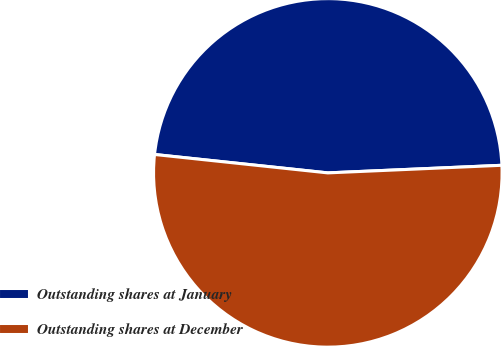<chart> <loc_0><loc_0><loc_500><loc_500><pie_chart><fcel>Outstanding shares at January<fcel>Outstanding shares at December<nl><fcel>47.62%<fcel>52.38%<nl></chart> 